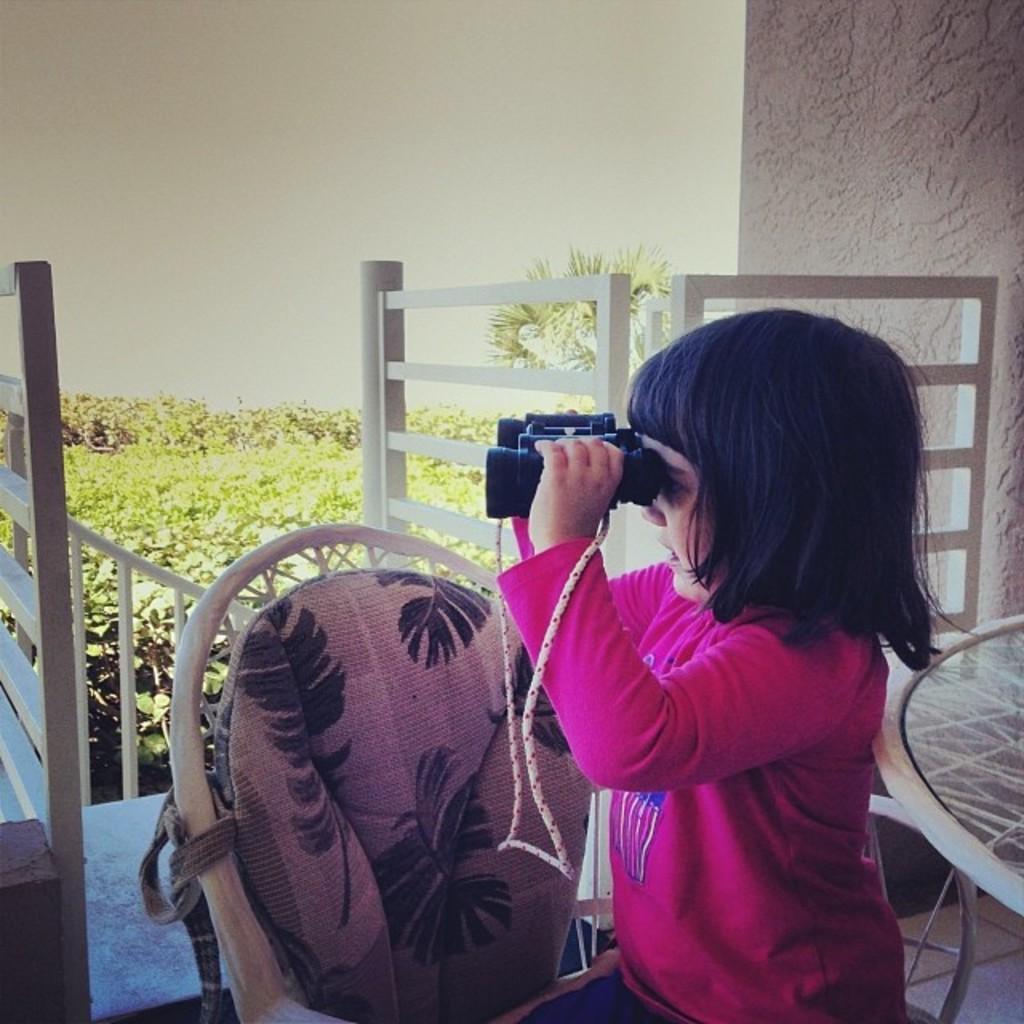In one or two sentences, can you explain what this image depicts? In the foreground of this image, there is a girl sitting on the hair holding binoculars. On the right, there is a table. In the background, there is white railing, plants, tree and on the right top, there is a pillar. On the top, there is unclear background. 